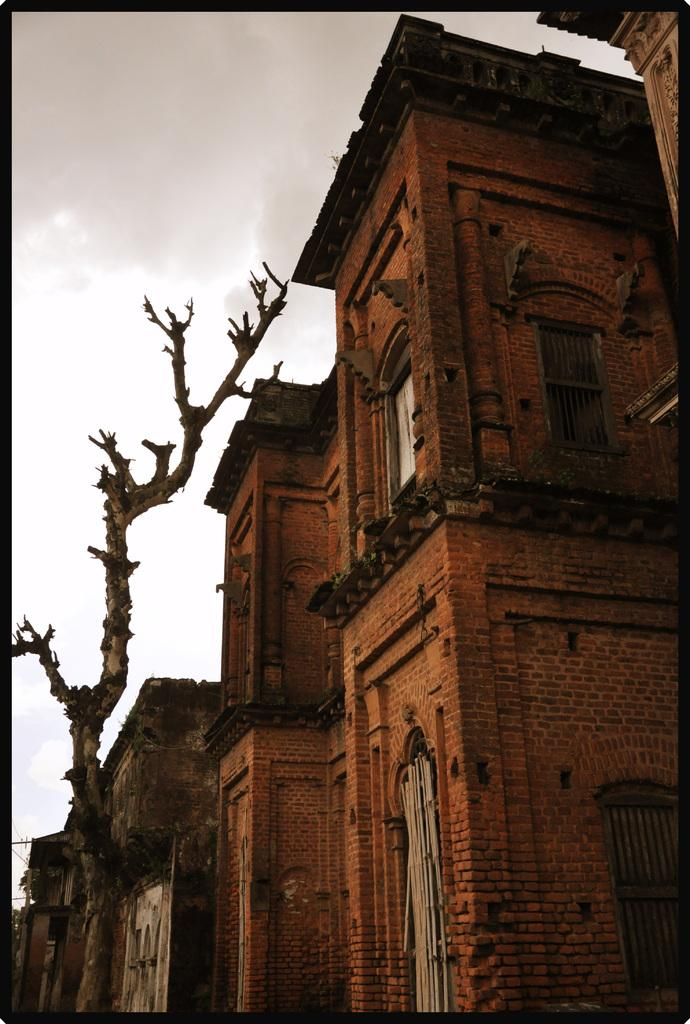What type of structure is in the image? There is a building in the image. What feature can be seen on the building? The building has windows. What is the color of the building? The building is brown in color. What object is located to the left of the building? There is a trunk to the left of the building. What can be seen in the background of the image? There are clouds and the sky visible in the background of the image. What type of pump is used to water the plants in the image? There are no plants or pumps visible in the image; it features a building, a trunk, and a background with clouds and the sky. 